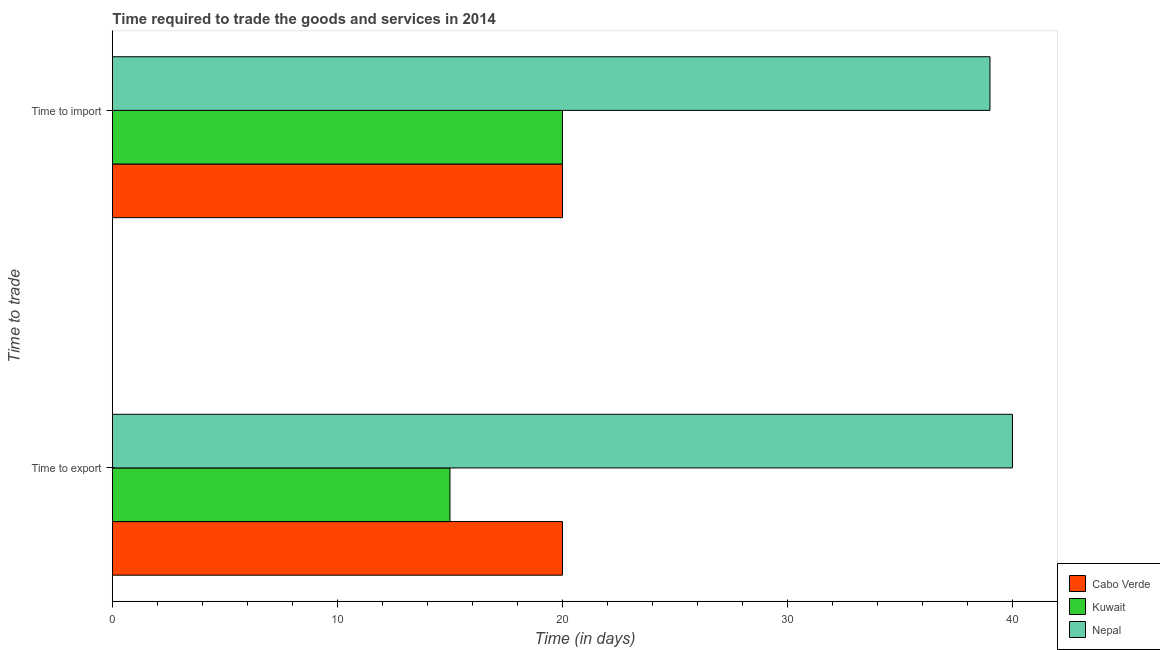Are the number of bars on each tick of the Y-axis equal?
Provide a succinct answer. Yes. How many bars are there on the 1st tick from the top?
Your answer should be very brief. 3. How many bars are there on the 1st tick from the bottom?
Your answer should be compact. 3. What is the label of the 1st group of bars from the top?
Offer a very short reply. Time to import. What is the time to import in Kuwait?
Provide a short and direct response. 20. Across all countries, what is the maximum time to import?
Ensure brevity in your answer.  39. Across all countries, what is the minimum time to export?
Your response must be concise. 15. In which country was the time to export maximum?
Offer a terse response. Nepal. In which country was the time to export minimum?
Your response must be concise. Kuwait. What is the total time to import in the graph?
Make the answer very short. 79. What is the difference between the time to import in Kuwait and that in Nepal?
Your response must be concise. -19. What is the difference between the time to export in Nepal and the time to import in Cabo Verde?
Ensure brevity in your answer.  20. What is the average time to export per country?
Your response must be concise. 25. What is the difference between the time to import and time to export in Kuwait?
Provide a short and direct response. 5. In how many countries, is the time to export greater than 18 days?
Your answer should be compact. 2. What is the ratio of the time to export in Nepal to that in Kuwait?
Provide a short and direct response. 2.67. Is the time to import in Nepal less than that in Cabo Verde?
Offer a terse response. No. In how many countries, is the time to export greater than the average time to export taken over all countries?
Offer a terse response. 1. What does the 1st bar from the top in Time to export represents?
Your response must be concise. Nepal. What does the 1st bar from the bottom in Time to export represents?
Provide a succinct answer. Cabo Verde. What is the difference between two consecutive major ticks on the X-axis?
Your answer should be very brief. 10. Are the values on the major ticks of X-axis written in scientific E-notation?
Ensure brevity in your answer.  No. Does the graph contain grids?
Provide a succinct answer. No. How many legend labels are there?
Offer a terse response. 3. What is the title of the graph?
Offer a terse response. Time required to trade the goods and services in 2014. Does "Burundi" appear as one of the legend labels in the graph?
Offer a terse response. No. What is the label or title of the X-axis?
Provide a short and direct response. Time (in days). What is the label or title of the Y-axis?
Ensure brevity in your answer.  Time to trade. What is the Time (in days) in Cabo Verde in Time to export?
Your answer should be compact. 20. What is the Time (in days) in Nepal in Time to export?
Your answer should be compact. 40. What is the Time (in days) in Cabo Verde in Time to import?
Offer a terse response. 20. What is the Time (in days) of Kuwait in Time to import?
Your answer should be compact. 20. What is the Time (in days) of Nepal in Time to import?
Provide a short and direct response. 39. Across all Time to trade, what is the maximum Time (in days) in Cabo Verde?
Your response must be concise. 20. Across all Time to trade, what is the minimum Time (in days) in Kuwait?
Offer a terse response. 15. What is the total Time (in days) in Cabo Verde in the graph?
Give a very brief answer. 40. What is the total Time (in days) in Nepal in the graph?
Your answer should be very brief. 79. What is the difference between the Time (in days) of Cabo Verde in Time to export and the Time (in days) of Kuwait in Time to import?
Your answer should be very brief. 0. What is the difference between the Time (in days) of Cabo Verde in Time to export and the Time (in days) of Nepal in Time to import?
Your response must be concise. -19. What is the difference between the Time (in days) in Kuwait in Time to export and the Time (in days) in Nepal in Time to import?
Provide a short and direct response. -24. What is the average Time (in days) of Cabo Verde per Time to trade?
Make the answer very short. 20. What is the average Time (in days) in Nepal per Time to trade?
Keep it short and to the point. 39.5. What is the difference between the Time (in days) of Cabo Verde and Time (in days) of Nepal in Time to export?
Your answer should be very brief. -20. What is the difference between the Time (in days) in Cabo Verde and Time (in days) in Kuwait in Time to import?
Your response must be concise. 0. What is the difference between the Time (in days) in Cabo Verde and Time (in days) in Nepal in Time to import?
Offer a terse response. -19. What is the difference between the Time (in days) in Kuwait and Time (in days) in Nepal in Time to import?
Offer a terse response. -19. What is the ratio of the Time (in days) of Kuwait in Time to export to that in Time to import?
Give a very brief answer. 0.75. What is the ratio of the Time (in days) of Nepal in Time to export to that in Time to import?
Make the answer very short. 1.03. What is the difference between the highest and the second highest Time (in days) in Nepal?
Provide a short and direct response. 1. What is the difference between the highest and the lowest Time (in days) of Kuwait?
Provide a short and direct response. 5. 